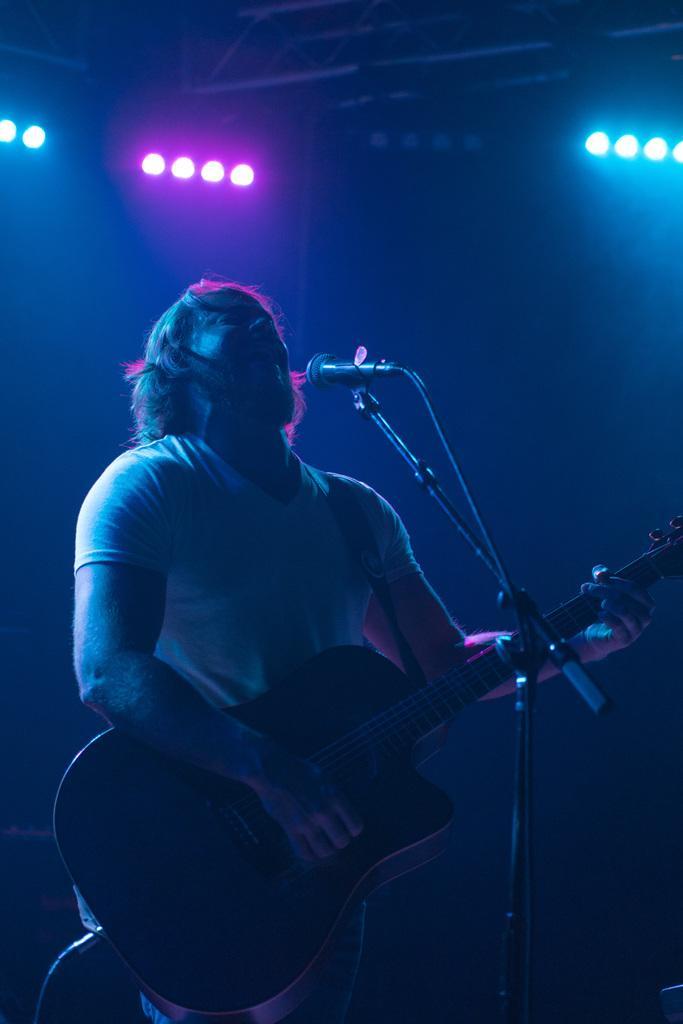Describe this image in one or two sentences. In this image there is a person standing and playing guitar and he is singing. At the front there is a microphone and at the top there are lights. 